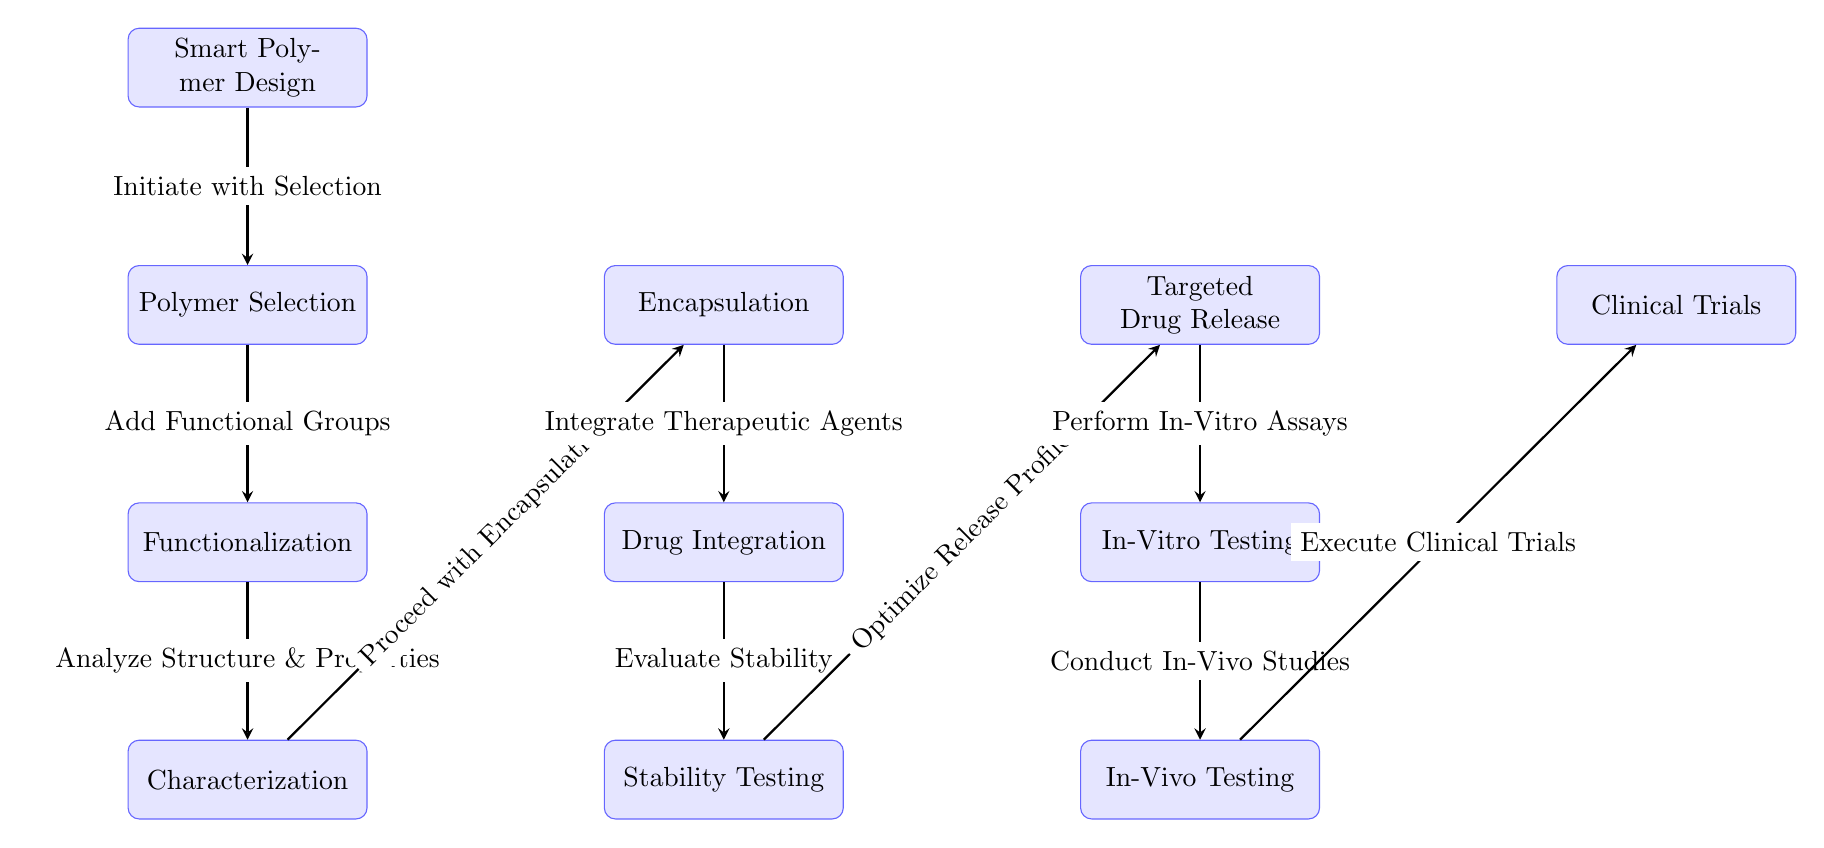What is the first step in the process? The first step in the diagram is "Smart Polymer Design," which is the starting point of the entire process flowchart.
Answer: Smart Polymer Design How many total processes are depicted in the diagram? By counting all the individual processes from "Smart Polymer Design" through to "Clinical Trials," we find there are 11 distinct processes listed.
Answer: 11 What comes immediately after "Characterization"? The process that follows "Characterization" is "Encapsulation," illustrated by an arrow pointing from "Characterization" to "Encapsulation."
Answer: Encapsulation Which process involves evaluating stability? "Stability Testing" is the distinct process where stability is evaluated, as shown in the flowchart connected from "Characterization" to "Stability Testing."
Answer: Stability Testing What are the two processes that occur after "Drug Integration"? The processes that occur after "Drug Integration" are "Stability Testing" and "In-Vitro Testing," following the flow of the diagram where "Drug Integration" is directly connected to "Stability Testing," which is then connected to "In-Vitro Testing."
Answer: Stability Testing and In-Vitro Testing What action follows "In-Vitro Testing" in the flowchart? The action that follows "In-Vitro Testing" is "In-Vivo Testing," as indicated by the connecting arrow leading to the next process after "In-Vitro Testing."
Answer: In-Vivo Testing What relationship is depicted between "Encapsulation" and "Drug Integration"? The diagram shows that after "Encapsulation," the next step is "Drug Integration," indicating a forward sequence in the drug delivery process where encapsulation supports the integration of drugs.
Answer: Encapsulation to Drug Integration Which two processes are linked by the arrow labeled "Add Functional Groups"? The processes linked by the "Add Functional Groups" arrow are "Polymer Selection" and "Functionalization," showcasing the integration of functional groups into the polymer following its selection.
Answer: Polymer Selection and Functionalization How many testing phases are included in the diagram? The diagram includes two testing phases: "In-Vitro Testing" and "In-Vivo Testing," as they are the only two processes explicitly related to testing.
Answer: 2 